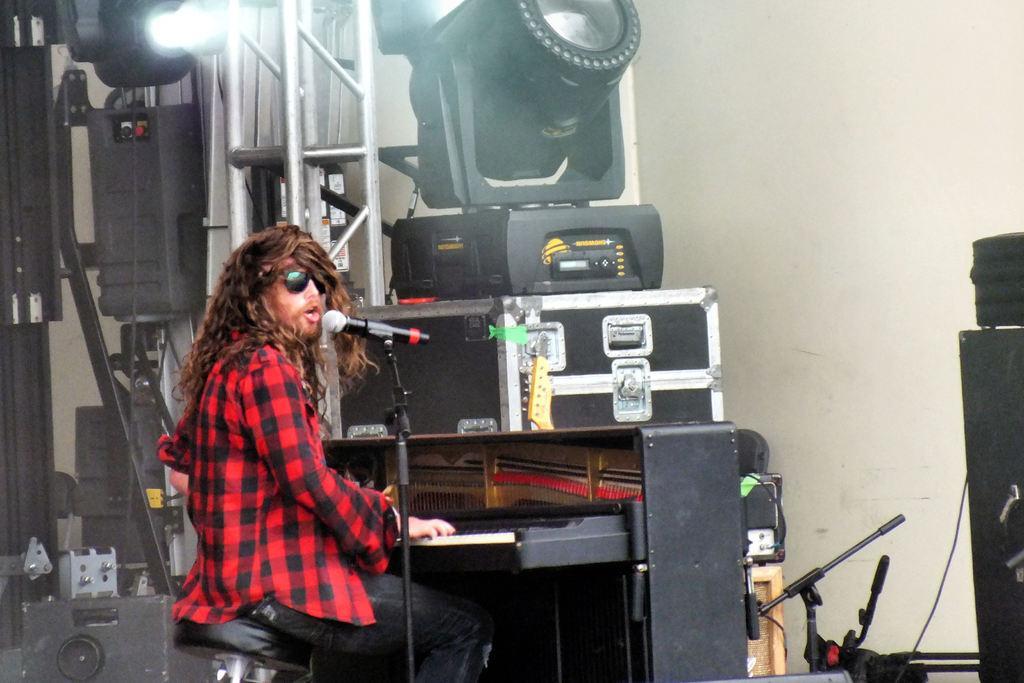Describe this image in one or two sentences. A focusing light. These are electronic devices. A man is sitting on a chair and playing a piano in-front of mic. A box. Rod. 